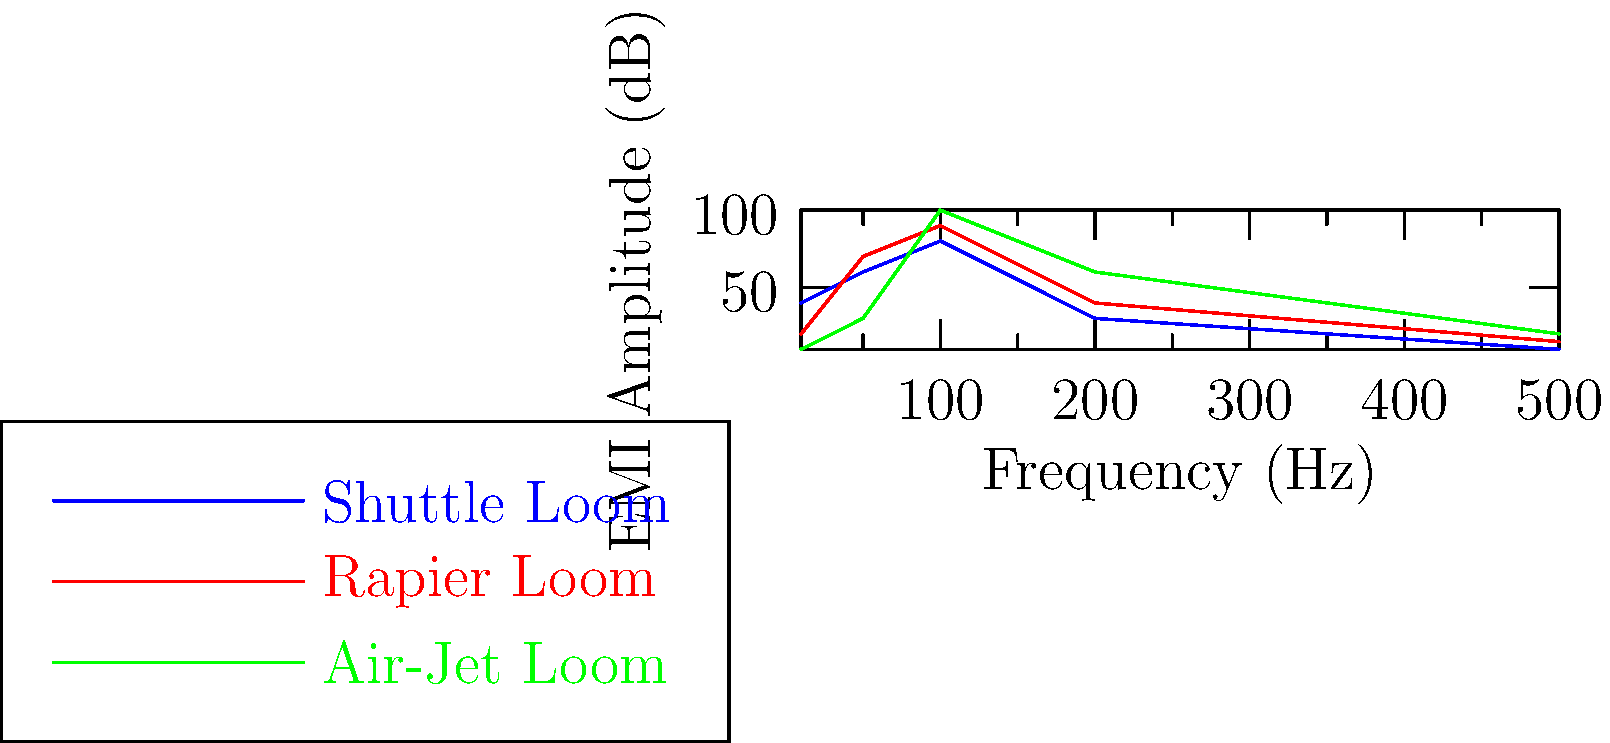Based on the frequency spectrum of electromagnetic interference (EMI) produced by different loom types shown in the graph, which type of loom exhibits the highest EMI amplitude at 100 Hz? To determine which loom type has the highest EMI amplitude at 100 Hz, we need to follow these steps:

1. Locate the 100 Hz point on the x-axis (frequency axis).
2. For each loom type, trace a vertical line from 100 Hz to where it intersects the corresponding graph line.
3. Compare the y-axis (EMI amplitude) values for each loom type at 100 Hz.

Analyzing the graph:

1. Shuttle Loom (blue line): At 100 Hz, the EMI amplitude is approximately 80 dB.
2. Rapier Loom (red line): At 100 Hz, the EMI amplitude is approximately 90 dB.
3. Air-Jet Loom (green line): At 100 Hz, the EMI amplitude is approximately 100 dB.

Comparing these values, we can see that the Air-Jet Loom has the highest EMI amplitude at 100 Hz, reaching about 100 dB.
Answer: Air-Jet Loom 